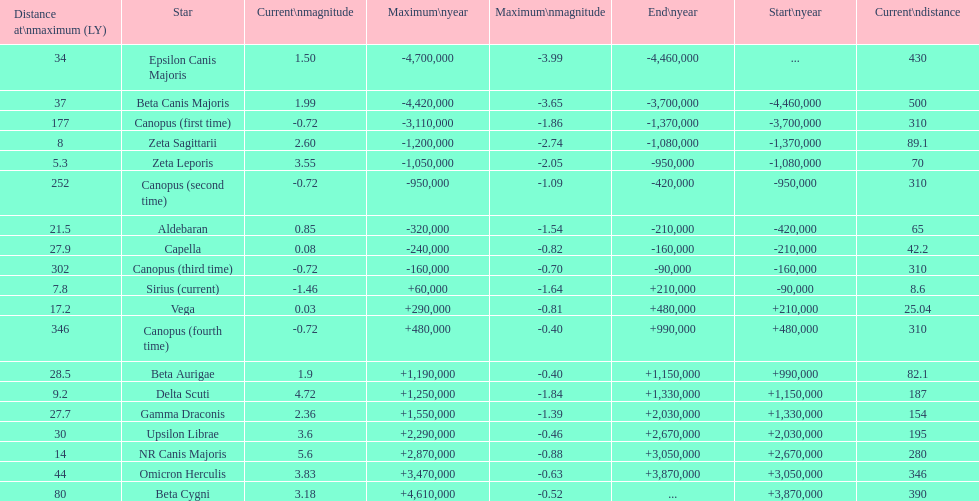What are the historical brightest stars? Epsilon Canis Majoris, Beta Canis Majoris, Canopus (first time), Zeta Sagittarii, Zeta Leporis, Canopus (second time), Aldebaran, Capella, Canopus (third time), Sirius (current), Vega, Canopus (fourth time), Beta Aurigae, Delta Scuti, Gamma Draconis, Upsilon Librae, NR Canis Majoris, Omicron Herculis, Beta Cygni. Of those which star has a distance at maximum of 80 Beta Cygni. 